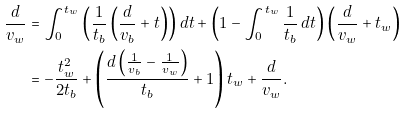Convert formula to latex. <formula><loc_0><loc_0><loc_500><loc_500>\frac { d } { v _ { w } } & = \int _ { 0 } ^ { t _ { w } } \left ( \frac { 1 } { t _ { b } } \left ( \frac { d } { v _ { b } } + t \right ) \right ) d t + \left ( 1 - \int _ { 0 } ^ { t _ { w } } \frac { 1 } { t _ { b } } \, d t \right ) \left ( \frac { d } { v _ { w } } + t _ { w } \right ) \\ & = - \frac { t _ { w } ^ { 2 } } { 2 t _ { b } } + \left ( \frac { d \left ( \frac { 1 } { v _ { b } } - \frac { 1 } { v _ { w } } \right ) } { t _ { b } } + 1 \right ) t _ { w } + \frac { d } { v _ { w } } .</formula> 